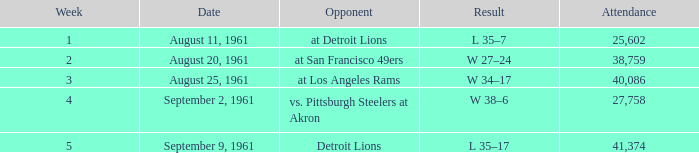Parse the table in full. {'header': ['Week', 'Date', 'Opponent', 'Result', 'Attendance'], 'rows': [['1', 'August 11, 1961', 'at Detroit Lions', 'L 35–7', '25,602'], ['2', 'August 20, 1961', 'at San Francisco 49ers', 'W 27–24', '38,759'], ['3', 'August 25, 1961', 'at Los Angeles Rams', 'W 34–17', '40,086'], ['4', 'September 2, 1961', 'vs. Pittsburgh Steelers at Akron', 'W 38–6', '27,758'], ['5', 'September 9, 1961', 'Detroit Lions', 'L 35–17', '41,374']]} What was the score of the Browns week 4 game? W 38–6. 